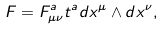<formula> <loc_0><loc_0><loc_500><loc_500>F = F ^ { a } _ { \mu \nu } t ^ { a } d x ^ { \mu } \wedge d x ^ { \nu } ,</formula> 